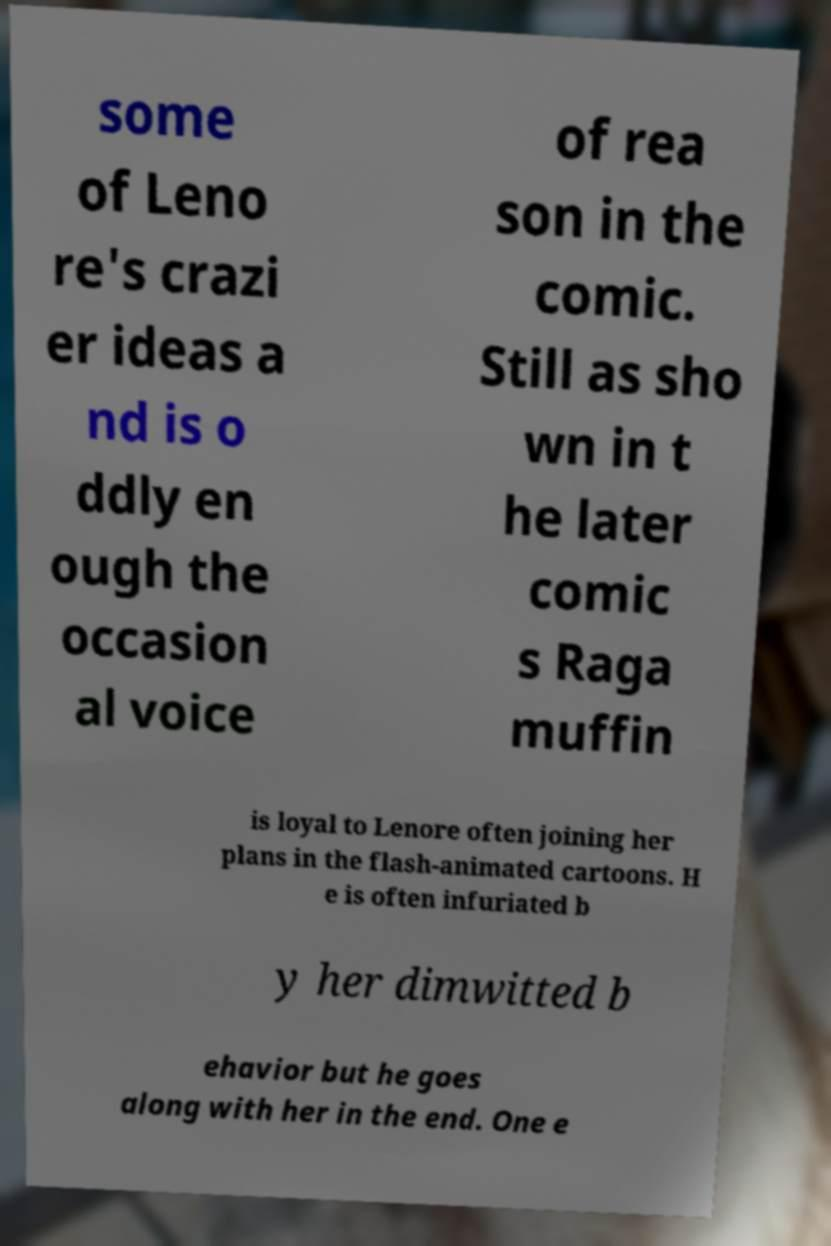Can you accurately transcribe the text from the provided image for me? some of Leno re's crazi er ideas a nd is o ddly en ough the occasion al voice of rea son in the comic. Still as sho wn in t he later comic s Raga muffin is loyal to Lenore often joining her plans in the flash-animated cartoons. H e is often infuriated b y her dimwitted b ehavior but he goes along with her in the end. One e 